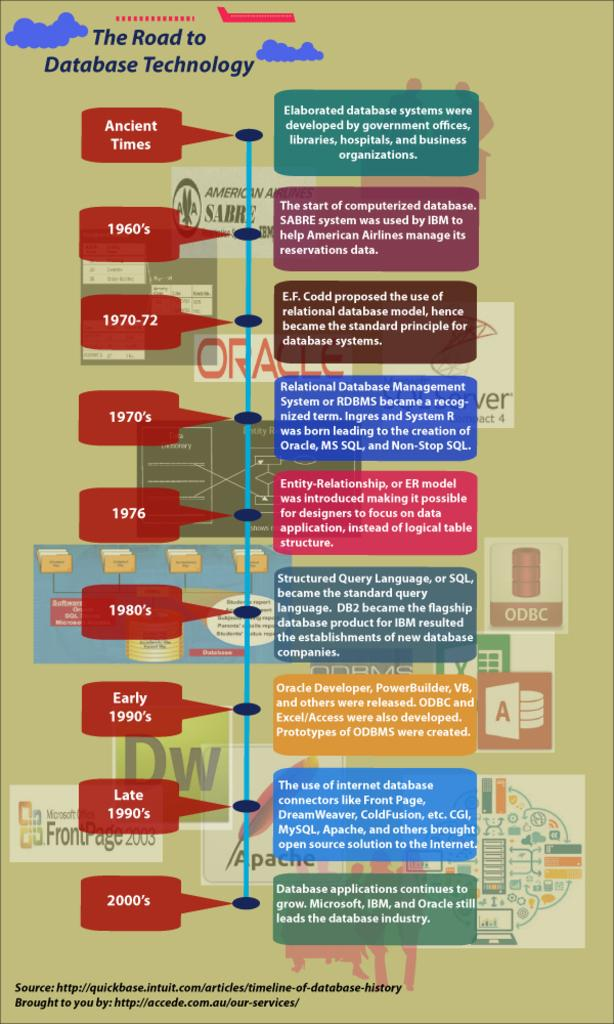<image>
Offer a succinct explanation of the picture presented. A graph titled The Road to Database Technology. 